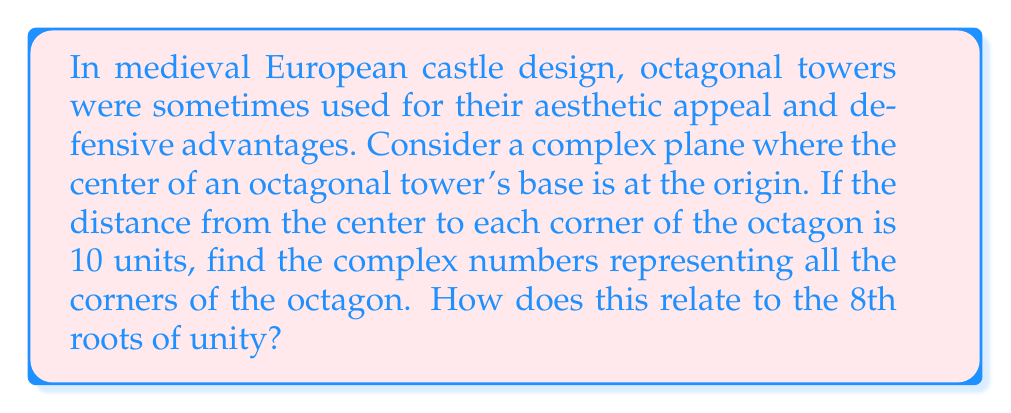Can you solve this math problem? To solve this problem, we need to understand the relationship between regular polygons and complex roots of unity. Let's approach this step-by-step:

1) The 8th roots of unity are given by the formula:
   
   $$\omega_k = e^{2\pi i k / 8}, \quad k = 0, 1, 2, ..., 7$$

2) These roots form a regular octagon on the complex plane when multiplied by any real number.

3) In our case, we want the distance from the center to each corner to be 10 units. So we need to multiply the 8th roots of unity by 10:

   $$z_k = 10e^{2\pi i k / 8}, \quad k = 0, 1, 2, ..., 7$$

4) Let's calculate these values:

   For $k = 0$: $z_0 = 10e^{0} = 10$
   For $k = 1$: $z_1 = 10e^{\pi i / 4} = 10(\cos(\pi/4) + i\sin(\pi/4)) = 10(\frac{\sqrt{2}}{2} + i\frac{\sqrt{2}}{2})$
   For $k = 2$: $z_2 = 10e^{\pi i / 2} = 10i$
   For $k = 3$: $z_3 = 10e^{3\pi i / 4} = 10(-\frac{\sqrt{2}}{2} + i\frac{\sqrt{2}}{2})$
   For $k = 4$: $z_4 = 10e^{\pi i} = -10$
   For $k = 5$: $z_5 = 10e^{5\pi i / 4} = 10(-\frac{\sqrt{2}}{2} - i\frac{\sqrt{2}}{2})$
   For $k = 6$: $z_6 = 10e^{3\pi i / 2} = -10i$
   For $k = 7$: $z_7 = 10e^{7\pi i / 4} = 10(\frac{\sqrt{2}}{2} - i\frac{\sqrt{2}}{2})$

5) These complex numbers represent the corners of the octagonal tower base.

6) The relationship to the 8th roots of unity is clear: the corners of the octagon are simply the 8th roots of unity scaled by a factor of 10.

This mathematical model relates directly to medieval castle design. The use of regular polygons, like octagons, in tower design was not only aesthetically pleasing but also provided better defensive capabilities. The symmetry of these shapes, represented mathematically by the complex roots of unity, allowed for better distribution of forces and improved structural integrity.
Answer: The complex numbers representing the corners of the octagonal tower base are:

$$z_k = 10e^{2\pi i k / 8}, \quad k = 0, 1, 2, ..., 7$$

Specifically:
$z_0 = 10$
$z_1 = 10(\frac{\sqrt{2}}{2} + i\frac{\sqrt{2}}{2})$
$z_2 = 10i$
$z_3 = 10(-\frac{\sqrt{2}}{2} + i\frac{\sqrt{2}}{2})$
$z_4 = -10$
$z_5 = 10(-\frac{\sqrt{2}}{2} - i\frac{\sqrt{2}}{2})$
$z_6 = -10i$
$z_7 = 10(\frac{\sqrt{2}}{2} - i\frac{\sqrt{2}}{2})$

These corners are directly related to the 8th roots of unity, being the roots scaled by a factor of 10. 